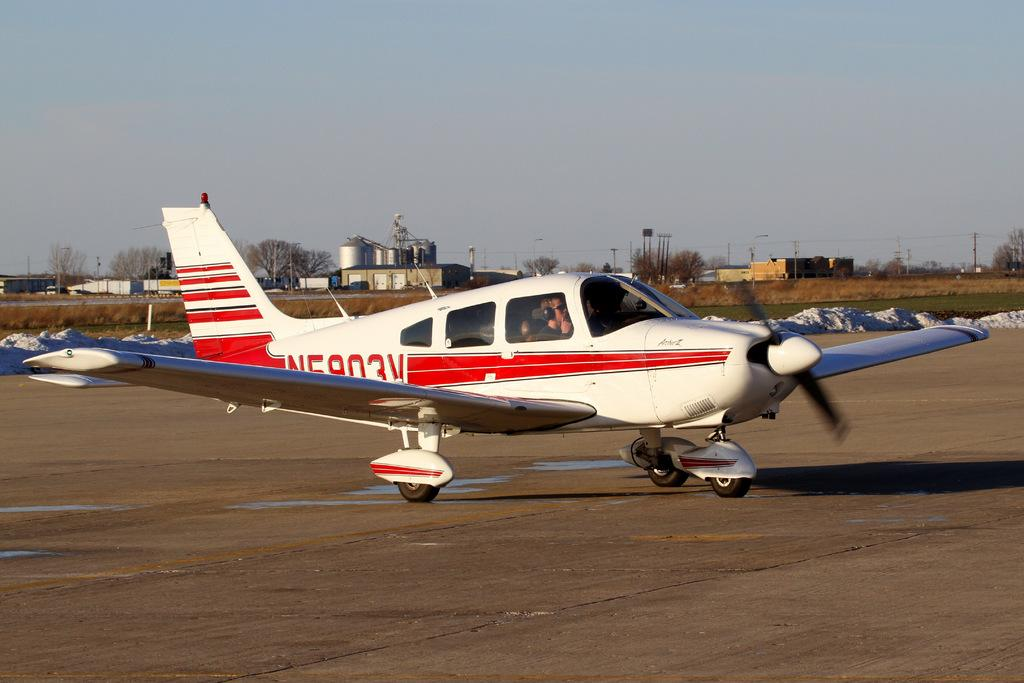Provide a one-sentence caption for the provided image. Charter Airplane shown with the label N5903V either taking off or landing. 